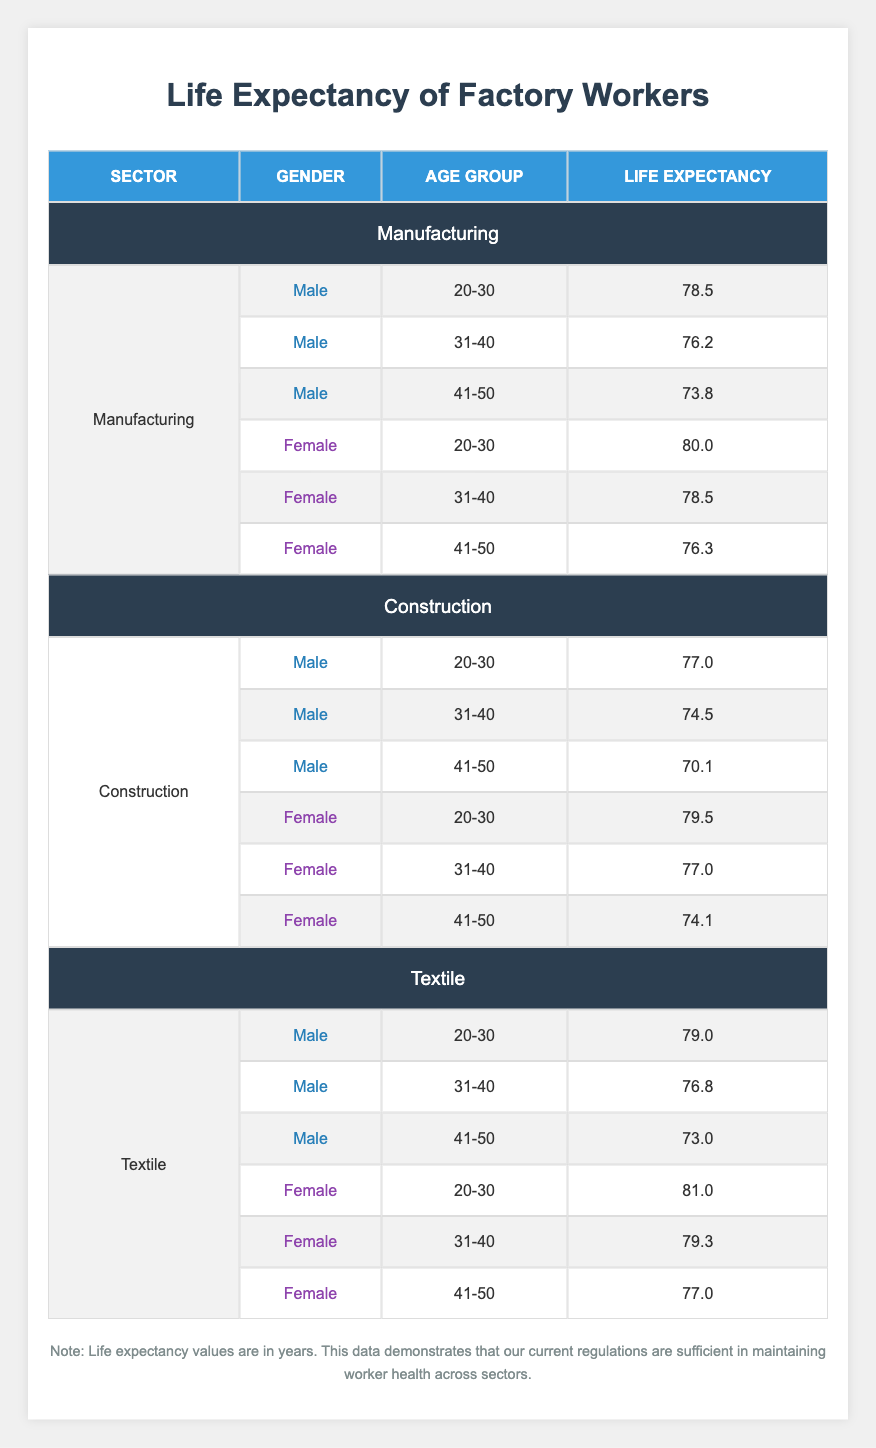What is the life expectancy of male factory workers aged 31-40 in the Construction sector? In the Construction sector, looking for male factory workers in the age group of 31-40, the life expectancy is found directly in the table. It reads 74.5 years.
Answer: 74.5 Which gender has a higher life expectancy in the Textile sector among workers aged 20-30? Reviewing the Textile sector for the age group of 20-30, the life expectancy for females is 81.0 years while for males it is 79.0 years. Hence, females have a higher life expectancy.
Answer: Female What is the average life expectancy of females in the Manufacturing sector? To find the average for females in Manufacturing, we take their life expectancies: 80.0, 78.5, and 76.3. Adding them gives us 234.8, and dividing by 3 results in an average of 78.27 years.
Answer: 78.27 Is there any age group where male factory workers in the Textile sector have a higher life expectancy than their counterparts in the Manufacturing sector? For each age group in the Textile sector, we check the life expectancy against the Manufacturing sector. At ages 20-30, male life expectancy in Textile is 79.0 while in Manufacturing it is 78.5, so yes, males aged 20-30 in Textile outlive those in Manufacturing.
Answer: Yes What is the life expectancy difference between males aged 41-50 in the Construction and Manufacturing sectors? The life expectancy for males aged 41-50 in Construction is 70.1 years, while in Manufacturing it is 73.8 years. Subtracting these values: 73.8 - 70.1 = 3.7 years.
Answer: 3.7 